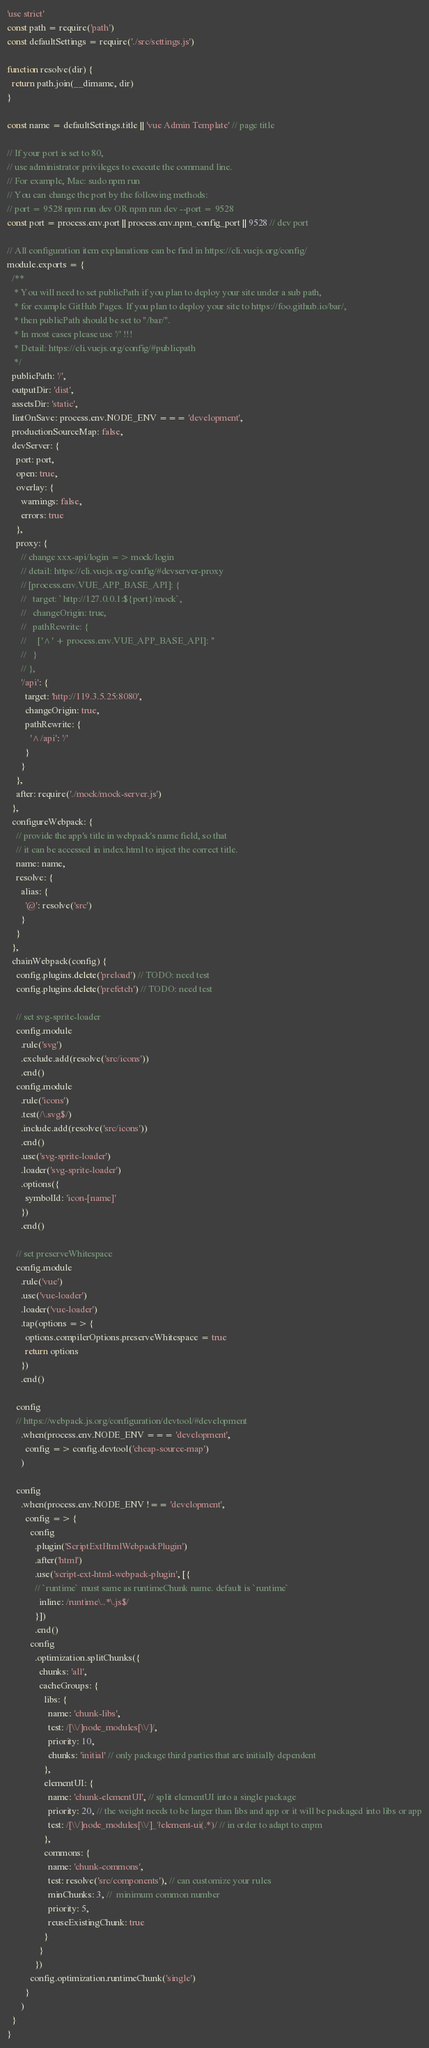<code> <loc_0><loc_0><loc_500><loc_500><_JavaScript_>'use strict'
const path = require('path')
const defaultSettings = require('./src/settings.js')

function resolve(dir) {
  return path.join(__dirname, dir)
}

const name = defaultSettings.title || 'vue Admin Template' // page title

// If your port is set to 80,
// use administrator privileges to execute the command line.
// For example, Mac: sudo npm run
// You can change the port by the following methods:
// port = 9528 npm run dev OR npm run dev --port = 9528
const port = process.env.port || process.env.npm_config_port || 9528 // dev port

// All configuration item explanations can be find in https://cli.vuejs.org/config/
module.exports = {
  /**
   * You will need to set publicPath if you plan to deploy your site under a sub path,
   * for example GitHub Pages. If you plan to deploy your site to https://foo.github.io/bar/,
   * then publicPath should be set to "/bar/".
   * In most cases please use '/' !!!
   * Detail: https://cli.vuejs.org/config/#publicpath
   */
  publicPath: '/',
  outputDir: 'dist',
  assetsDir: 'static',
  lintOnSave: process.env.NODE_ENV === 'development',
  productionSourceMap: false,
  devServer: {
    port: port,
    open: true,
    overlay: {
      warnings: false,
      errors: true
    },
    proxy: {
      // change xxx-api/login => mock/login
      // detail: https://cli.vuejs.org/config/#devserver-proxy
      // [process.env.VUE_APP_BASE_API]: {
      //   target: `http://127.0.0.1:${port}/mock`,
      //   changeOrigin: true,
      //   pathRewrite: {
      //     ['^' + process.env.VUE_APP_BASE_API]: ''
      //   }
      // },
      '/api': {
        target: 'http://119.3.5.25:8080',
        changeOrigin: true,
        pathRewrite: {
          '^/api': '/'
        }
      }
    },
    after: require('./mock/mock-server.js')
  },
  configureWebpack: {
    // provide the app's title in webpack's name field, so that
    // it can be accessed in index.html to inject the correct title.
    name: name,
    resolve: {
      alias: {
        '@': resolve('src')
      }
    }
  },
  chainWebpack(config) {
    config.plugins.delete('preload') // TODO: need test
    config.plugins.delete('prefetch') // TODO: need test

    // set svg-sprite-loader
    config.module
      .rule('svg')
      .exclude.add(resolve('src/icons'))
      .end()
    config.module
      .rule('icons')
      .test(/\.svg$/)
      .include.add(resolve('src/icons'))
      .end()
      .use('svg-sprite-loader')
      .loader('svg-sprite-loader')
      .options({
        symbolId: 'icon-[name]'
      })
      .end()

    // set preserveWhitespace
    config.module
      .rule('vue')
      .use('vue-loader')
      .loader('vue-loader')
      .tap(options => {
        options.compilerOptions.preserveWhitespace = true
        return options
      })
      .end()

    config
    // https://webpack.js.org/configuration/devtool/#development
      .when(process.env.NODE_ENV === 'development',
        config => config.devtool('cheap-source-map')
      )

    config
      .when(process.env.NODE_ENV !== 'development',
        config => {
          config
            .plugin('ScriptExtHtmlWebpackPlugin')
            .after('html')
            .use('script-ext-html-webpack-plugin', [{
            // `runtime` must same as runtimeChunk name. default is `runtime`
              inline: /runtime\..*\.js$/
            }])
            .end()
          config
            .optimization.splitChunks({
              chunks: 'all',
              cacheGroups: {
                libs: {
                  name: 'chunk-libs',
                  test: /[\\/]node_modules[\\/]/,
                  priority: 10,
                  chunks: 'initial' // only package third parties that are initially dependent
                },
                elementUI: {
                  name: 'chunk-elementUI', // split elementUI into a single package
                  priority: 20, // the weight needs to be larger than libs and app or it will be packaged into libs or app
                  test: /[\\/]node_modules[\\/]_?element-ui(.*)/ // in order to adapt to cnpm
                },
                commons: {
                  name: 'chunk-commons',
                  test: resolve('src/components'), // can customize your rules
                  minChunks: 3, //  minimum common number
                  priority: 5,
                  reuseExistingChunk: true
                }
              }
            })
          config.optimization.runtimeChunk('single')
        }
      )
  }
}
</code> 